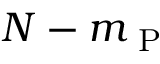Convert formula to latex. <formula><loc_0><loc_0><loc_500><loc_500>N - m _ { P }</formula> 